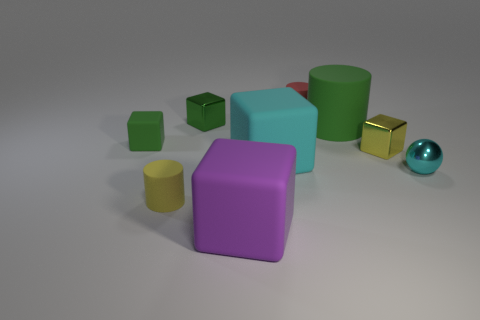Subtract all purple blocks. How many blocks are left? 4 Subtract all tiny rubber blocks. How many blocks are left? 4 Subtract all blue blocks. Subtract all cyan spheres. How many blocks are left? 5 Add 1 large rubber cubes. How many objects exist? 10 Subtract all cylinders. How many objects are left? 6 Subtract 0 brown cylinders. How many objects are left? 9 Subtract all cyan spheres. Subtract all big cyan rubber blocks. How many objects are left? 7 Add 3 rubber cylinders. How many rubber cylinders are left? 6 Add 2 big yellow matte blocks. How many big yellow matte blocks exist? 2 